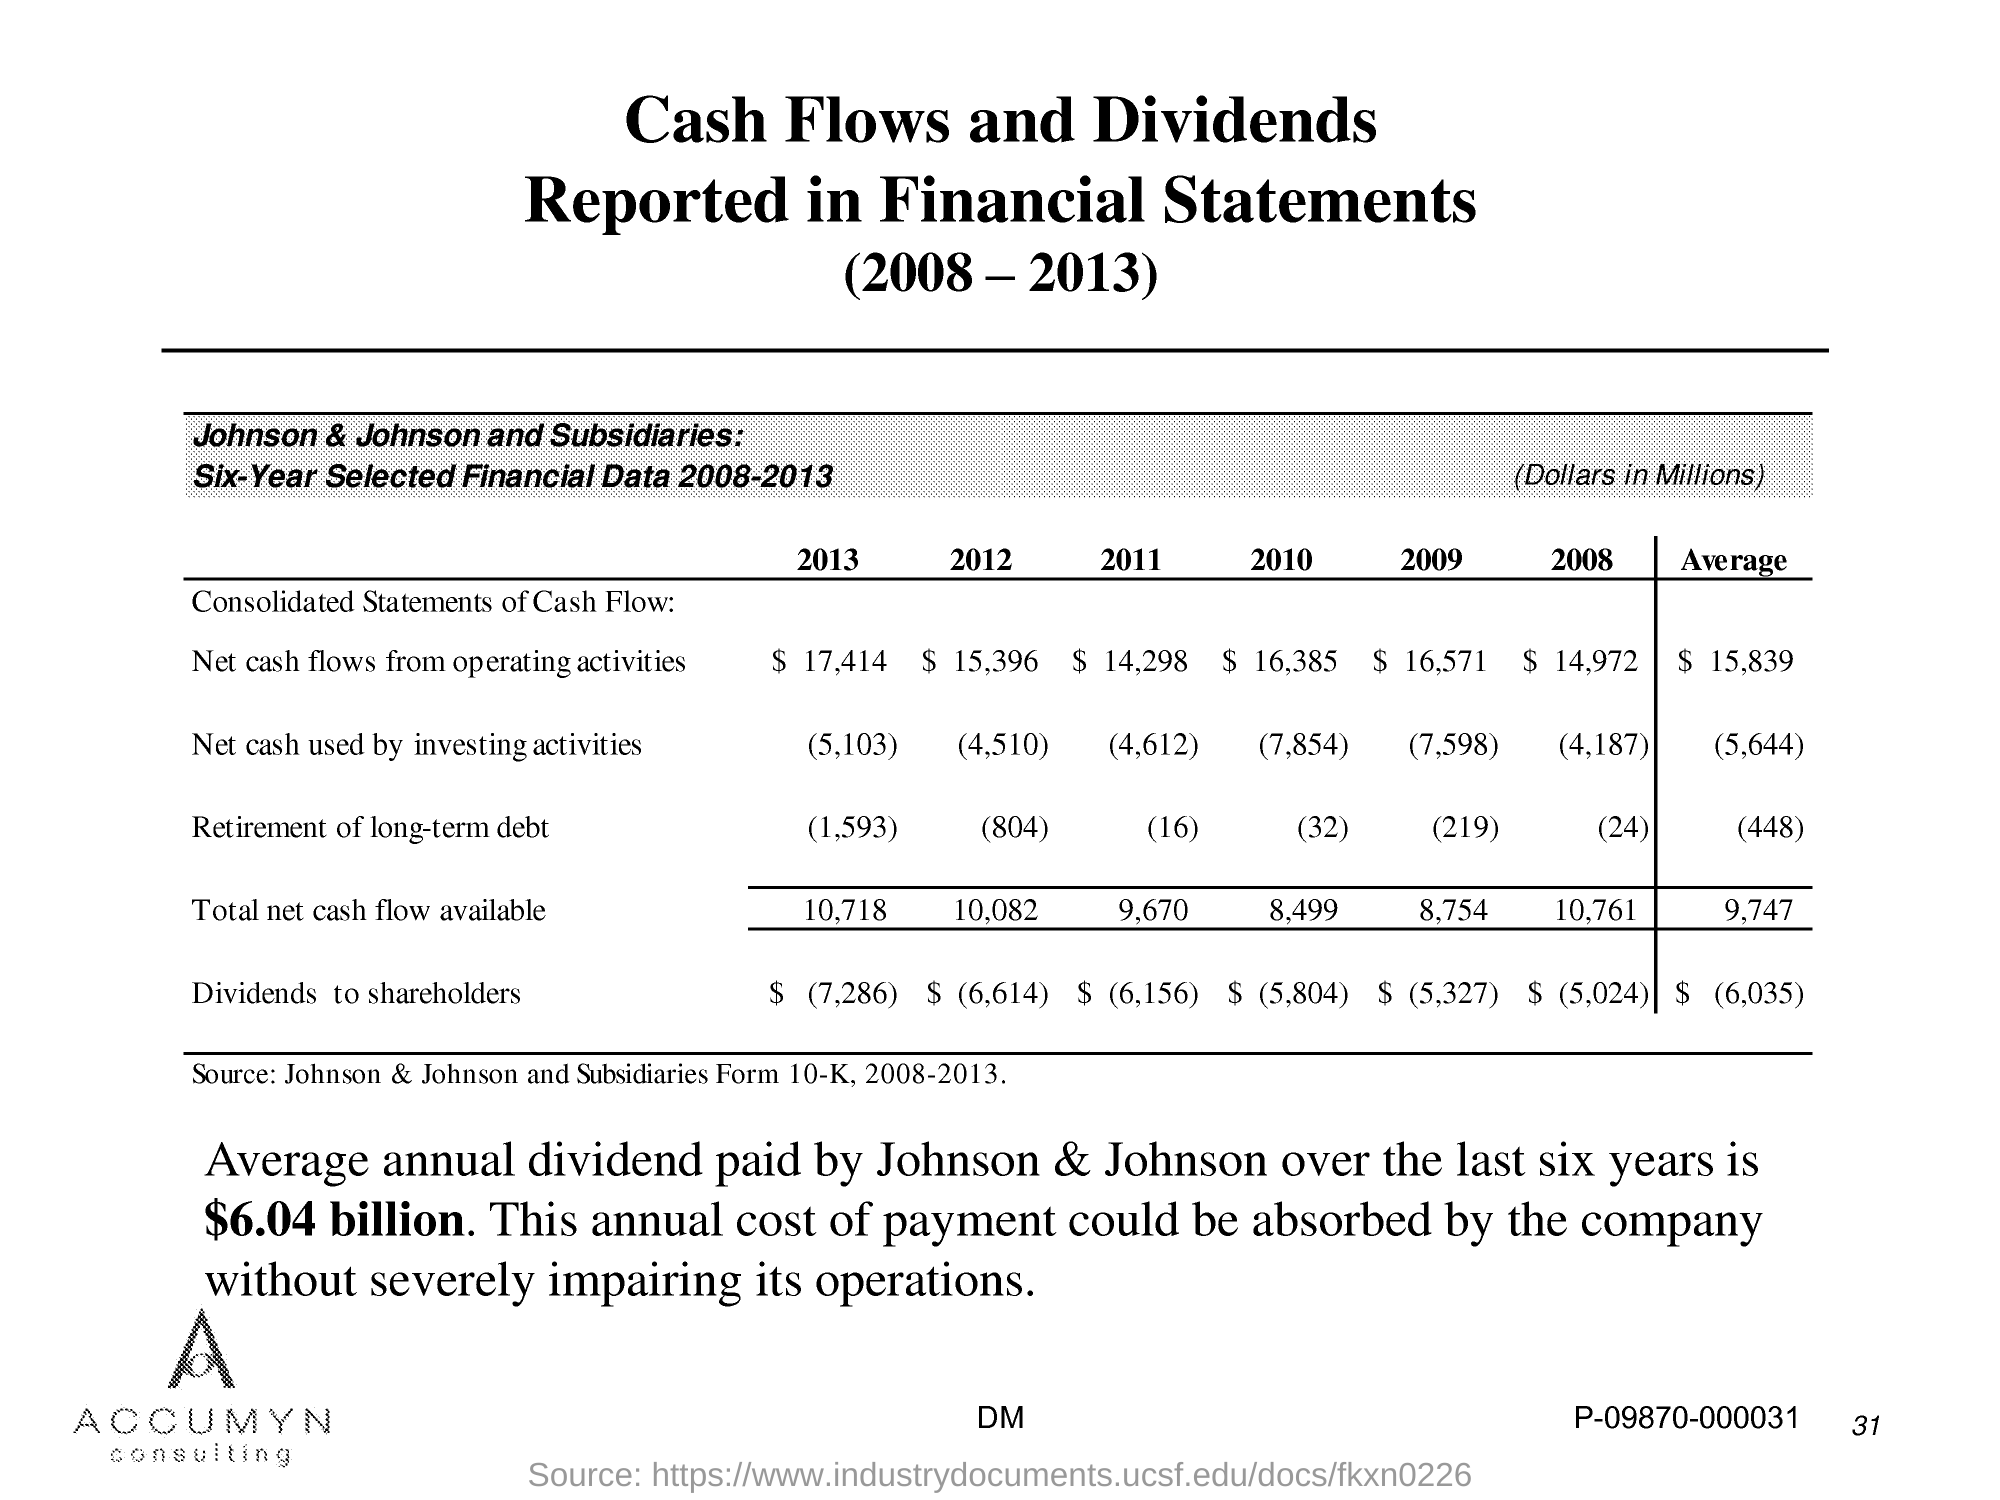What is the source of the data in the table?
Your answer should be very brief. Johnson & Johnson and Subsidiaries Form 10-K, 2008-2013. What is the average annual dividend paid by Johnson & Johnson over the last six years?
Ensure brevity in your answer.  $6.04 billion. 